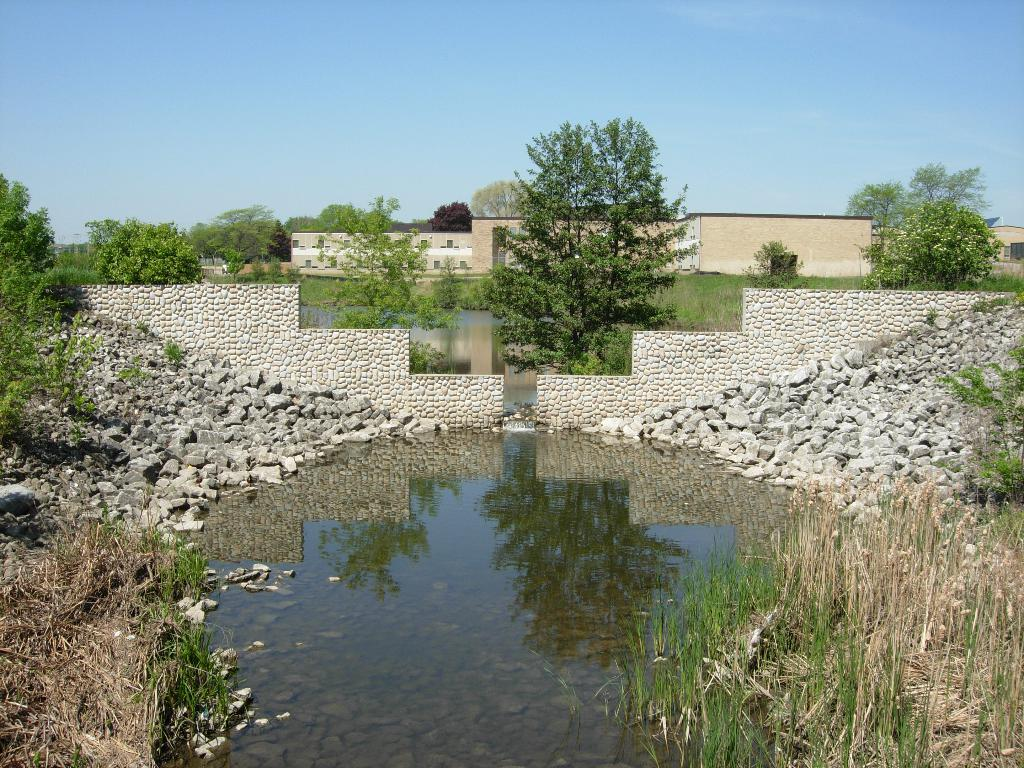What is the primary element visible in the image? There is water in the image. What other natural elements can be seen in the image? There are rocks, grass, and plants visible in the image. What can be seen in the background of the image? There are buildings and trees in the background of the image. What is the color of the sky in the image? The sky is blue in the image. What type of decision can be seen being made in the image? There is no decision-making process visible in the image; it primarily features natural elements and a blue sky. Can you identify a lamp in the image? There is no lamp present in the image. 